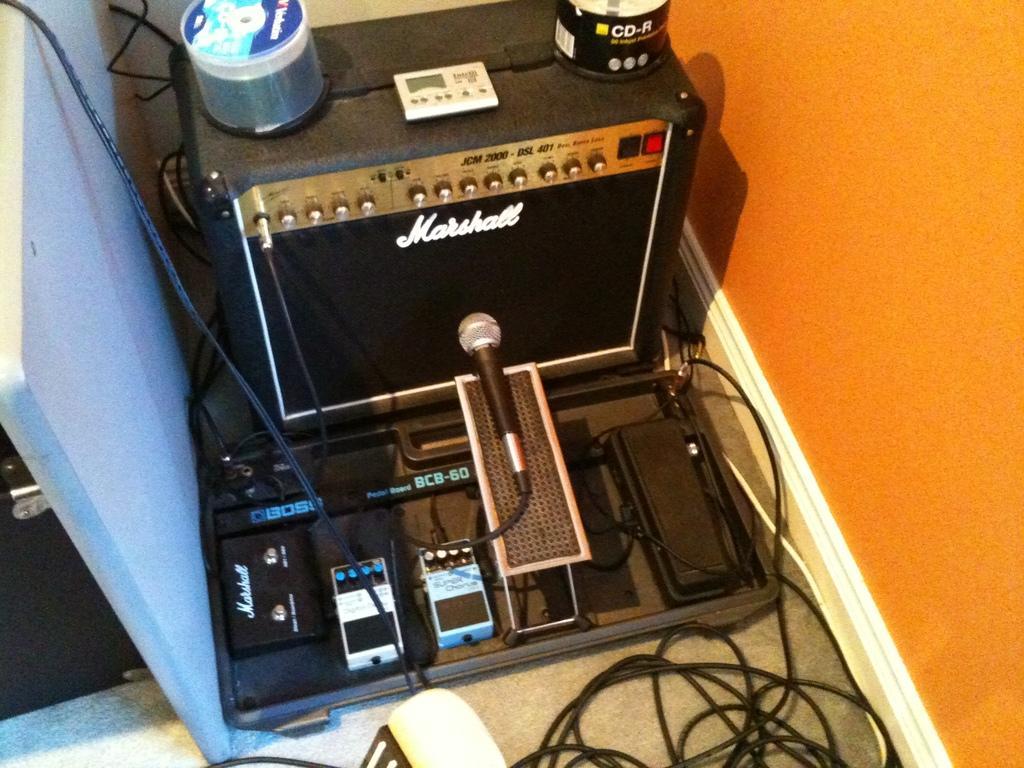Please provide a concise description of this image. In this picture there is a device on the top. At the bottom, there is a mike. At the bottom right, there are wires. 